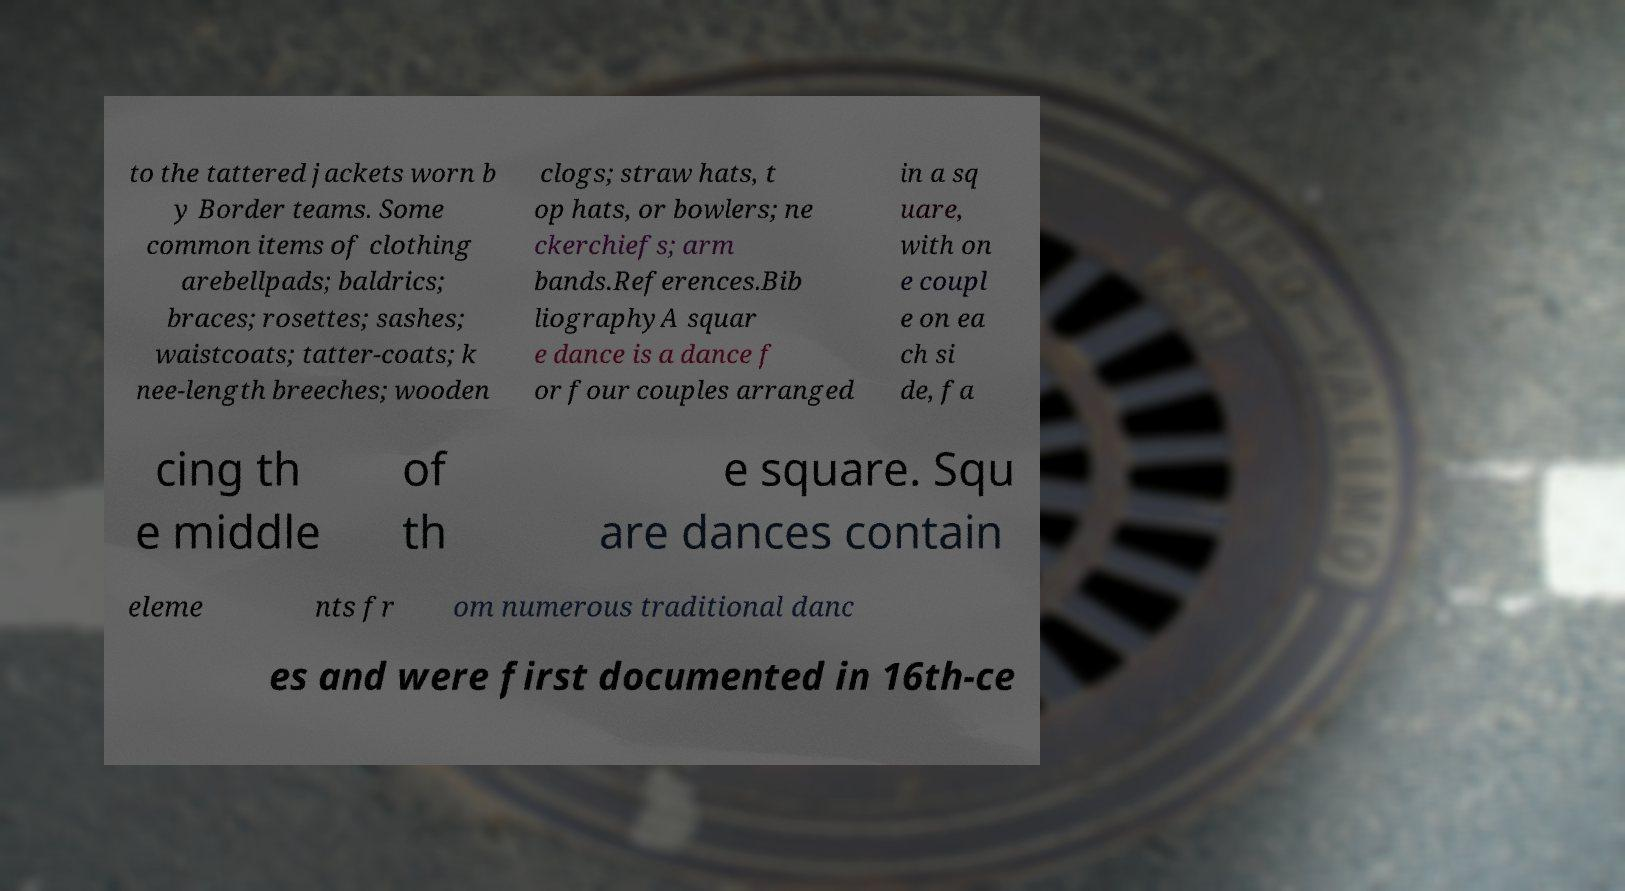I need the written content from this picture converted into text. Can you do that? to the tattered jackets worn b y Border teams. Some common items of clothing arebellpads; baldrics; braces; rosettes; sashes; waistcoats; tatter-coats; k nee-length breeches; wooden clogs; straw hats, t op hats, or bowlers; ne ckerchiefs; arm bands.References.Bib liographyA squar e dance is a dance f or four couples arranged in a sq uare, with on e coupl e on ea ch si de, fa cing th e middle of th e square. Squ are dances contain eleme nts fr om numerous traditional danc es and were first documented in 16th-ce 